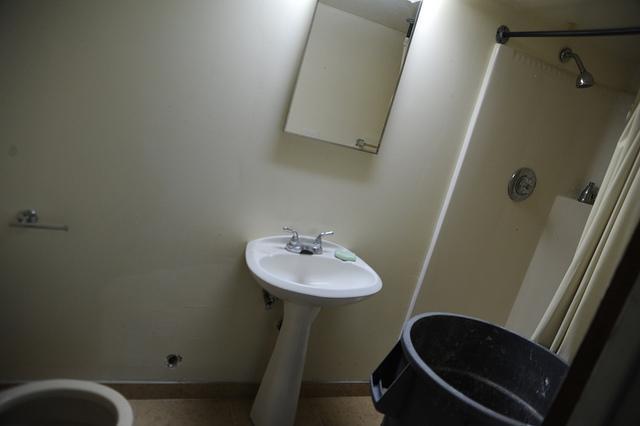How many sinks are in the photo?
Give a very brief answer. 1. 